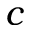Convert formula to latex. <formula><loc_0><loc_0><loc_500><loc_500>c</formula> 